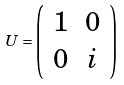Convert formula to latex. <formula><loc_0><loc_0><loc_500><loc_500>U = \left ( \begin{array} { c c } 1 & 0 \\ 0 & i \end{array} \right )</formula> 